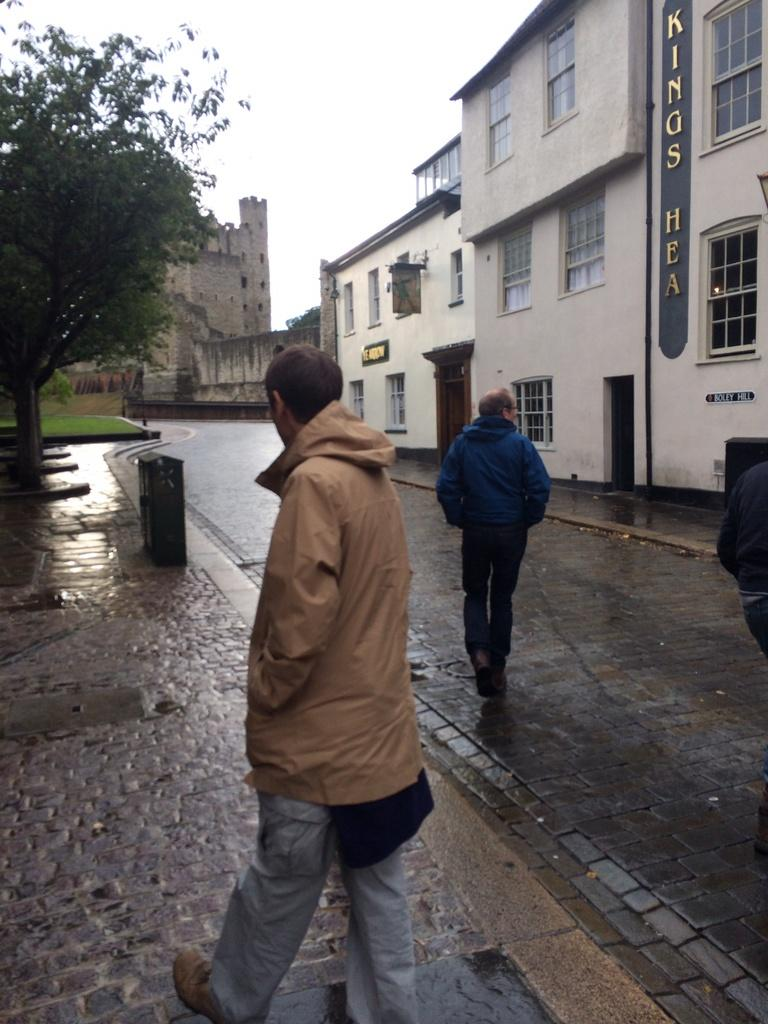How many people are present in the image? There are three people in the image. What are two of the people doing in the image? Two of the people are walking on the road. What type of vegetation can be seen in the image? There are trees in the image. What type of structures are visible in the image? There are buildings with windows in the image. What is visible in the background of the image? The sky is visible in the background of the image. Can you tell me how many kittens are jumping over the geese in the image? There are no kittens or geese present in the image. 